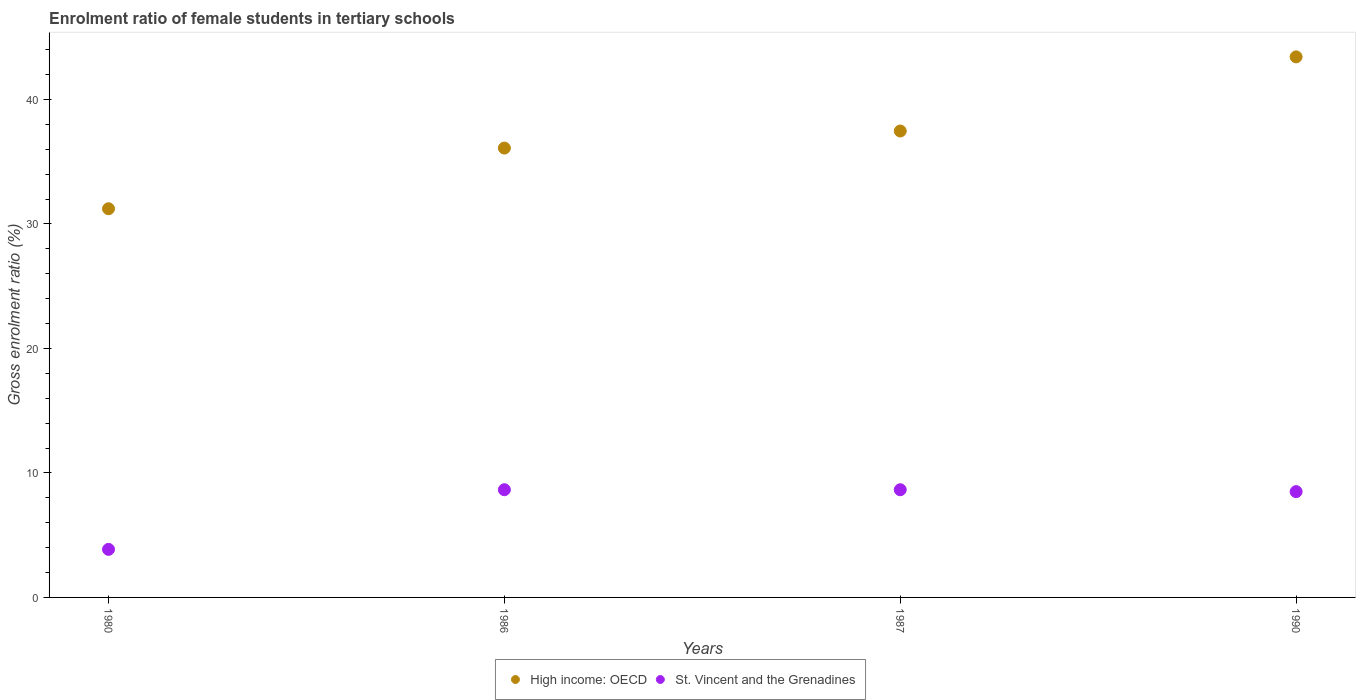What is the enrolment ratio of female students in tertiary schools in St. Vincent and the Grenadines in 1990?
Provide a short and direct response. 8.5. Across all years, what is the maximum enrolment ratio of female students in tertiary schools in High income: OECD?
Your response must be concise. 43.43. Across all years, what is the minimum enrolment ratio of female students in tertiary schools in St. Vincent and the Grenadines?
Provide a short and direct response. 3.86. In which year was the enrolment ratio of female students in tertiary schools in High income: OECD maximum?
Offer a very short reply. 1990. In which year was the enrolment ratio of female students in tertiary schools in High income: OECD minimum?
Provide a short and direct response. 1980. What is the total enrolment ratio of female students in tertiary schools in St. Vincent and the Grenadines in the graph?
Make the answer very short. 29.66. What is the difference between the enrolment ratio of female students in tertiary schools in High income: OECD in 1980 and that in 1990?
Provide a short and direct response. -12.2. What is the difference between the enrolment ratio of female students in tertiary schools in High income: OECD in 1986 and the enrolment ratio of female students in tertiary schools in St. Vincent and the Grenadines in 1987?
Provide a succinct answer. 27.45. What is the average enrolment ratio of female students in tertiary schools in St. Vincent and the Grenadines per year?
Make the answer very short. 7.42. In the year 1990, what is the difference between the enrolment ratio of female students in tertiary schools in St. Vincent and the Grenadines and enrolment ratio of female students in tertiary schools in High income: OECD?
Provide a short and direct response. -34.93. In how many years, is the enrolment ratio of female students in tertiary schools in High income: OECD greater than 24 %?
Provide a short and direct response. 4. What is the ratio of the enrolment ratio of female students in tertiary schools in High income: OECD in 1980 to that in 1986?
Offer a very short reply. 0.86. Is the enrolment ratio of female students in tertiary schools in High income: OECD in 1980 less than that in 1986?
Your answer should be very brief. Yes. What is the difference between the highest and the second highest enrolment ratio of female students in tertiary schools in High income: OECD?
Ensure brevity in your answer.  5.96. What is the difference between the highest and the lowest enrolment ratio of female students in tertiary schools in St. Vincent and the Grenadines?
Keep it short and to the point. 4.79. Is the enrolment ratio of female students in tertiary schools in St. Vincent and the Grenadines strictly greater than the enrolment ratio of female students in tertiary schools in High income: OECD over the years?
Ensure brevity in your answer.  No. Is the enrolment ratio of female students in tertiary schools in High income: OECD strictly less than the enrolment ratio of female students in tertiary schools in St. Vincent and the Grenadines over the years?
Keep it short and to the point. No. How many dotlines are there?
Your answer should be compact. 2. What is the difference between two consecutive major ticks on the Y-axis?
Provide a short and direct response. 10. Does the graph contain any zero values?
Provide a succinct answer. No. Does the graph contain grids?
Your answer should be very brief. No. How many legend labels are there?
Your answer should be compact. 2. How are the legend labels stacked?
Ensure brevity in your answer.  Horizontal. What is the title of the graph?
Provide a short and direct response. Enrolment ratio of female students in tertiary schools. Does "Lesotho" appear as one of the legend labels in the graph?
Ensure brevity in your answer.  No. What is the Gross enrolment ratio (%) in High income: OECD in 1980?
Your answer should be compact. 31.22. What is the Gross enrolment ratio (%) in St. Vincent and the Grenadines in 1980?
Provide a short and direct response. 3.86. What is the Gross enrolment ratio (%) in High income: OECD in 1986?
Your answer should be compact. 36.1. What is the Gross enrolment ratio (%) of St. Vincent and the Grenadines in 1986?
Provide a short and direct response. 8.65. What is the Gross enrolment ratio (%) in High income: OECD in 1987?
Offer a terse response. 37.47. What is the Gross enrolment ratio (%) in St. Vincent and the Grenadines in 1987?
Give a very brief answer. 8.65. What is the Gross enrolment ratio (%) in High income: OECD in 1990?
Provide a short and direct response. 43.43. What is the Gross enrolment ratio (%) in St. Vincent and the Grenadines in 1990?
Your response must be concise. 8.5. Across all years, what is the maximum Gross enrolment ratio (%) of High income: OECD?
Keep it short and to the point. 43.43. Across all years, what is the maximum Gross enrolment ratio (%) in St. Vincent and the Grenadines?
Give a very brief answer. 8.65. Across all years, what is the minimum Gross enrolment ratio (%) in High income: OECD?
Give a very brief answer. 31.22. Across all years, what is the minimum Gross enrolment ratio (%) in St. Vincent and the Grenadines?
Give a very brief answer. 3.86. What is the total Gross enrolment ratio (%) in High income: OECD in the graph?
Provide a succinct answer. 148.22. What is the total Gross enrolment ratio (%) in St. Vincent and the Grenadines in the graph?
Ensure brevity in your answer.  29.66. What is the difference between the Gross enrolment ratio (%) of High income: OECD in 1980 and that in 1986?
Offer a very short reply. -4.87. What is the difference between the Gross enrolment ratio (%) of St. Vincent and the Grenadines in 1980 and that in 1986?
Offer a terse response. -4.79. What is the difference between the Gross enrolment ratio (%) of High income: OECD in 1980 and that in 1987?
Keep it short and to the point. -6.24. What is the difference between the Gross enrolment ratio (%) in St. Vincent and the Grenadines in 1980 and that in 1987?
Keep it short and to the point. -4.79. What is the difference between the Gross enrolment ratio (%) in High income: OECD in 1980 and that in 1990?
Provide a short and direct response. -12.2. What is the difference between the Gross enrolment ratio (%) of St. Vincent and the Grenadines in 1980 and that in 1990?
Give a very brief answer. -4.64. What is the difference between the Gross enrolment ratio (%) in High income: OECD in 1986 and that in 1987?
Ensure brevity in your answer.  -1.37. What is the difference between the Gross enrolment ratio (%) in St. Vincent and the Grenadines in 1986 and that in 1987?
Give a very brief answer. 0. What is the difference between the Gross enrolment ratio (%) in High income: OECD in 1986 and that in 1990?
Provide a succinct answer. -7.33. What is the difference between the Gross enrolment ratio (%) of St. Vincent and the Grenadines in 1986 and that in 1990?
Offer a very short reply. 0.15. What is the difference between the Gross enrolment ratio (%) in High income: OECD in 1987 and that in 1990?
Provide a succinct answer. -5.96. What is the difference between the Gross enrolment ratio (%) of St. Vincent and the Grenadines in 1987 and that in 1990?
Your answer should be very brief. 0.15. What is the difference between the Gross enrolment ratio (%) in High income: OECD in 1980 and the Gross enrolment ratio (%) in St. Vincent and the Grenadines in 1986?
Keep it short and to the point. 22.57. What is the difference between the Gross enrolment ratio (%) in High income: OECD in 1980 and the Gross enrolment ratio (%) in St. Vincent and the Grenadines in 1987?
Keep it short and to the point. 22.57. What is the difference between the Gross enrolment ratio (%) of High income: OECD in 1980 and the Gross enrolment ratio (%) of St. Vincent and the Grenadines in 1990?
Offer a very short reply. 22.73. What is the difference between the Gross enrolment ratio (%) of High income: OECD in 1986 and the Gross enrolment ratio (%) of St. Vincent and the Grenadines in 1987?
Ensure brevity in your answer.  27.45. What is the difference between the Gross enrolment ratio (%) in High income: OECD in 1986 and the Gross enrolment ratio (%) in St. Vincent and the Grenadines in 1990?
Make the answer very short. 27.6. What is the difference between the Gross enrolment ratio (%) in High income: OECD in 1987 and the Gross enrolment ratio (%) in St. Vincent and the Grenadines in 1990?
Provide a succinct answer. 28.97. What is the average Gross enrolment ratio (%) in High income: OECD per year?
Provide a short and direct response. 37.05. What is the average Gross enrolment ratio (%) in St. Vincent and the Grenadines per year?
Keep it short and to the point. 7.42. In the year 1980, what is the difference between the Gross enrolment ratio (%) of High income: OECD and Gross enrolment ratio (%) of St. Vincent and the Grenadines?
Your answer should be very brief. 27.36. In the year 1986, what is the difference between the Gross enrolment ratio (%) of High income: OECD and Gross enrolment ratio (%) of St. Vincent and the Grenadines?
Provide a short and direct response. 27.45. In the year 1987, what is the difference between the Gross enrolment ratio (%) in High income: OECD and Gross enrolment ratio (%) in St. Vincent and the Grenadines?
Ensure brevity in your answer.  28.82. In the year 1990, what is the difference between the Gross enrolment ratio (%) in High income: OECD and Gross enrolment ratio (%) in St. Vincent and the Grenadines?
Ensure brevity in your answer.  34.93. What is the ratio of the Gross enrolment ratio (%) in High income: OECD in 1980 to that in 1986?
Offer a terse response. 0.86. What is the ratio of the Gross enrolment ratio (%) in St. Vincent and the Grenadines in 1980 to that in 1986?
Your answer should be compact. 0.45. What is the ratio of the Gross enrolment ratio (%) of St. Vincent and the Grenadines in 1980 to that in 1987?
Offer a terse response. 0.45. What is the ratio of the Gross enrolment ratio (%) of High income: OECD in 1980 to that in 1990?
Your answer should be compact. 0.72. What is the ratio of the Gross enrolment ratio (%) in St. Vincent and the Grenadines in 1980 to that in 1990?
Your answer should be compact. 0.45. What is the ratio of the Gross enrolment ratio (%) in High income: OECD in 1986 to that in 1987?
Offer a very short reply. 0.96. What is the ratio of the Gross enrolment ratio (%) in High income: OECD in 1986 to that in 1990?
Provide a succinct answer. 0.83. What is the ratio of the Gross enrolment ratio (%) of St. Vincent and the Grenadines in 1986 to that in 1990?
Provide a short and direct response. 1.02. What is the ratio of the Gross enrolment ratio (%) in High income: OECD in 1987 to that in 1990?
Your response must be concise. 0.86. What is the ratio of the Gross enrolment ratio (%) in St. Vincent and the Grenadines in 1987 to that in 1990?
Provide a short and direct response. 1.02. What is the difference between the highest and the second highest Gross enrolment ratio (%) in High income: OECD?
Your response must be concise. 5.96. What is the difference between the highest and the second highest Gross enrolment ratio (%) in St. Vincent and the Grenadines?
Give a very brief answer. 0. What is the difference between the highest and the lowest Gross enrolment ratio (%) in High income: OECD?
Your answer should be very brief. 12.2. What is the difference between the highest and the lowest Gross enrolment ratio (%) of St. Vincent and the Grenadines?
Give a very brief answer. 4.79. 